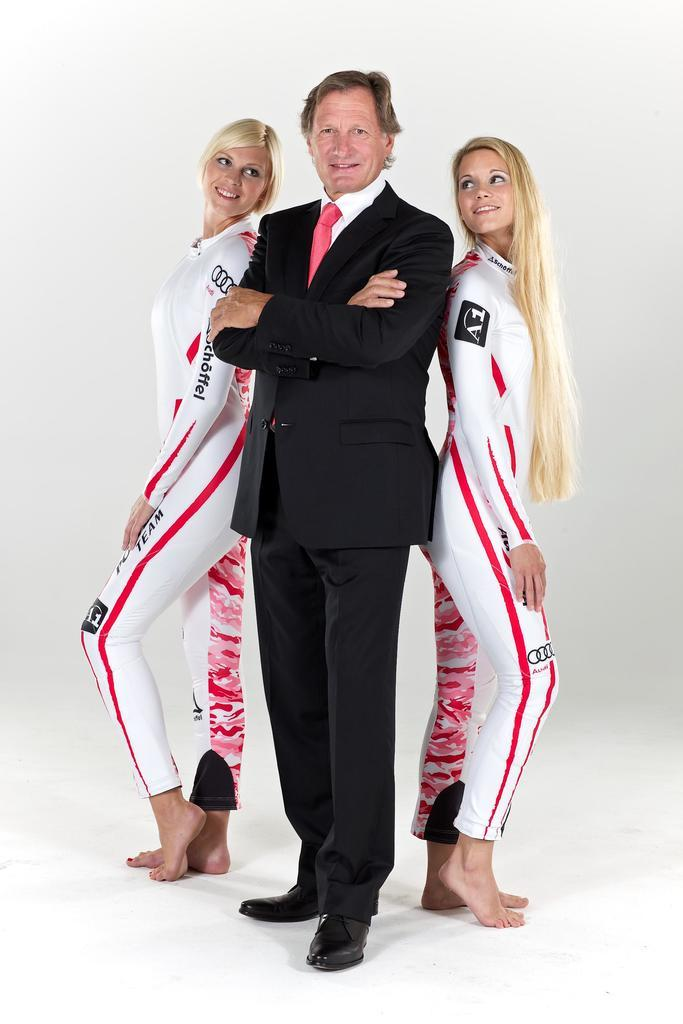Who is present in the image? There is a man and two women in the image. What is the man wearing? The man is wearing a black suit. How are the women depicted in the image? The women are smiling and standing on the floor. How many ants can be seen crawling on the man's suit in the image? There are no ants present in the image, so none can be seen crawling on the man's suit. What is the relation between the man and the two women in the image? The provided facts do not give any information about the relationship between the man and the two women, so it cannot be determined from the image. 